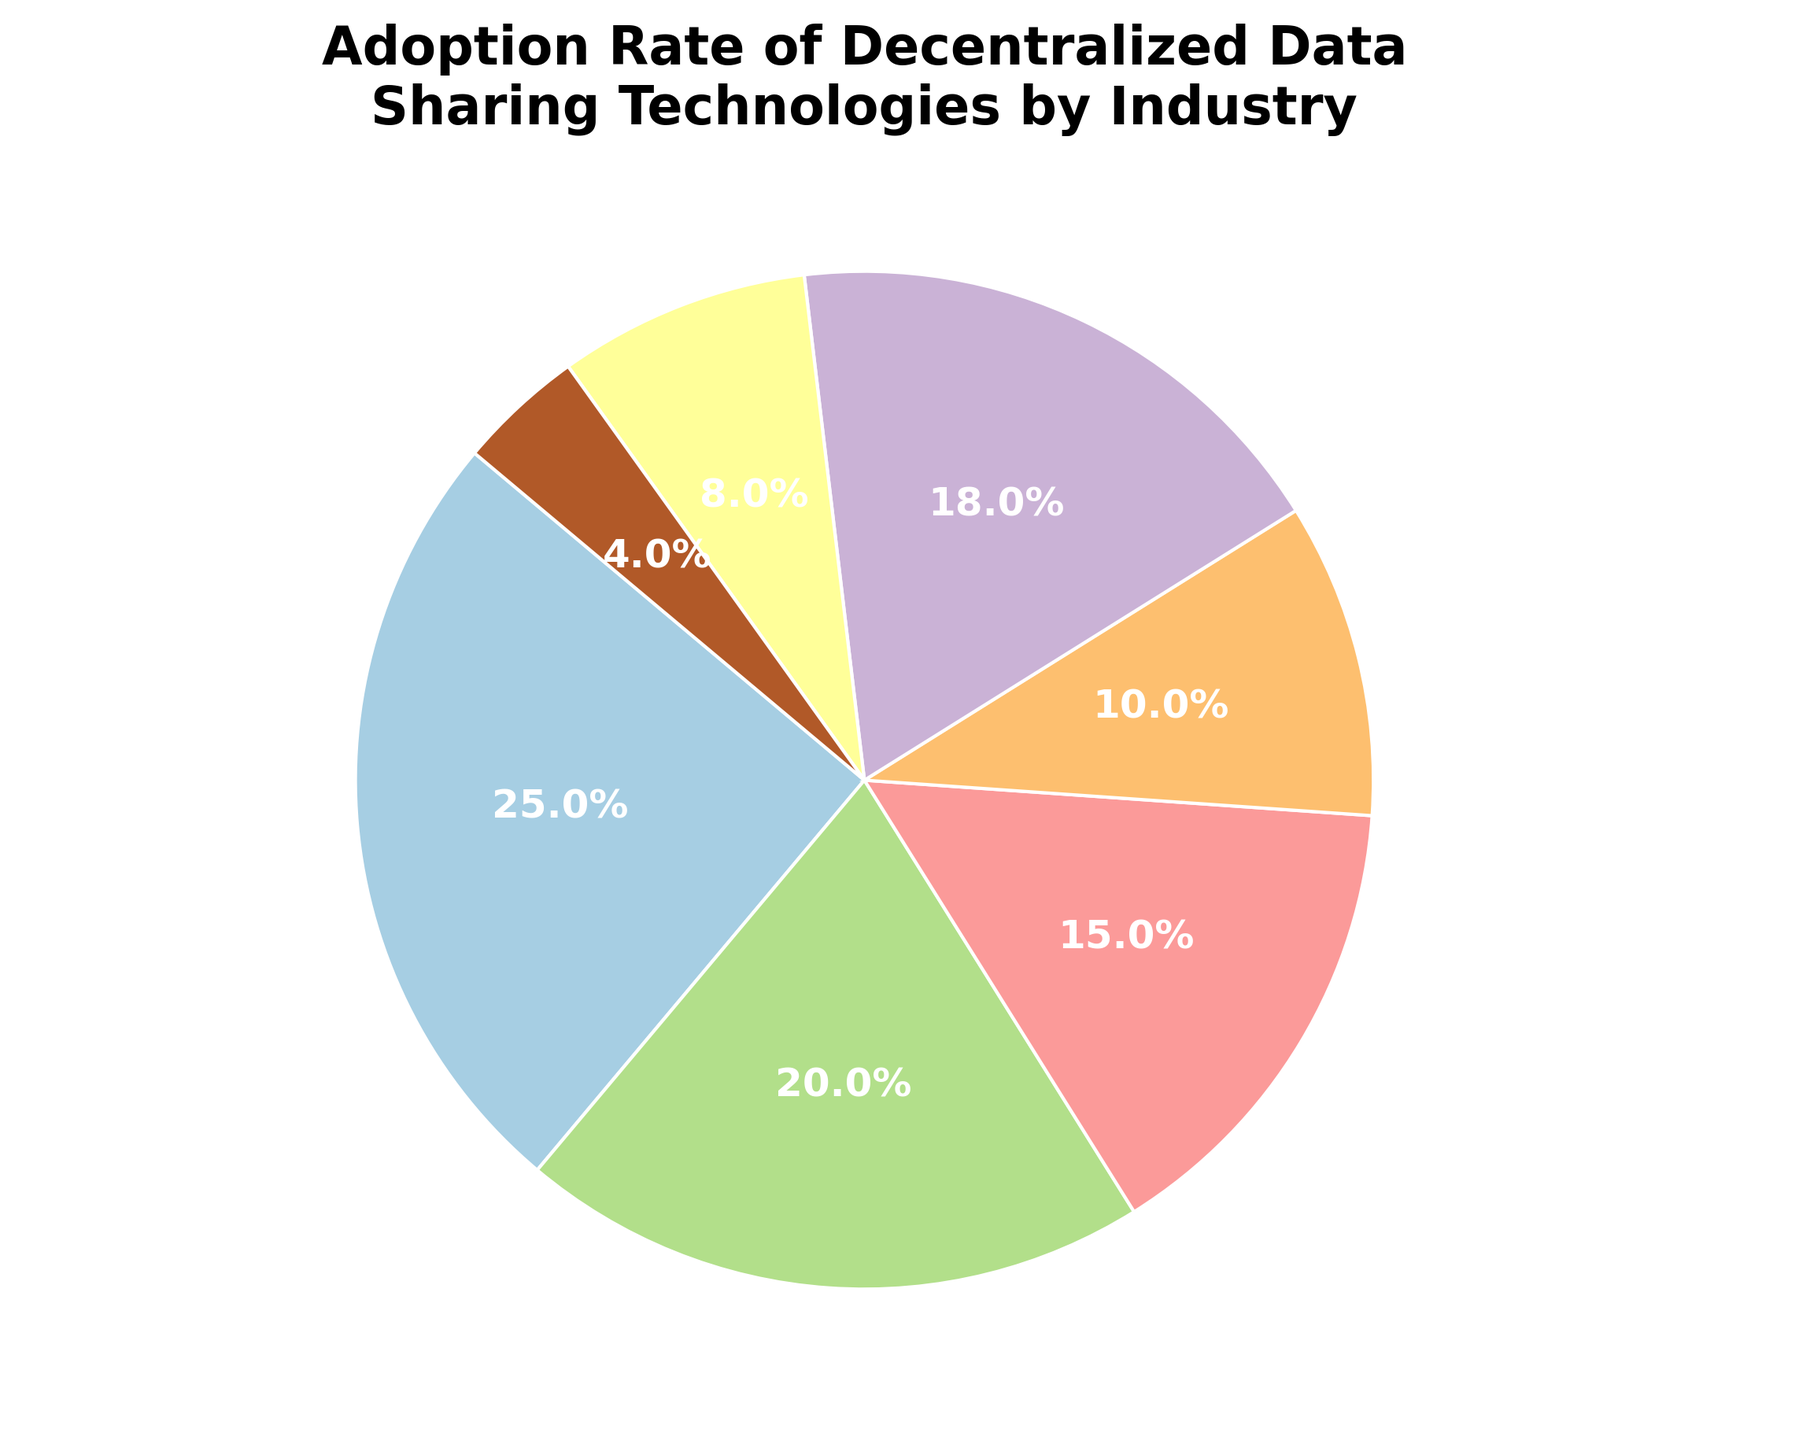What industry has the highest adoption rate of decentralized data sharing technologies? From the pie chart, the slice representing the Healthcare sector is the largest, indicating that it has the highest adoption rate.
Answer: Healthcare Which industry has a lower adoption rate: Finance or Technology? By comparing the sizes of the wedges, it is clear that the Finance sector's wedge is slightly larger than the Technology sector's wedge, meaning Technology has a lower adoption rate.
Answer: Technology What is the combined adoption rate of the Public Sector and Education industries? The Public Sector has an adoption rate of 8% and Education has 4%. Adding these two percentages gives 8% + 4% = 12%.
Answer: 12% Which two industries have the most similar adoption rates, and what are those rates? The Technology industry has an adoption rate of 18% and the Finance industry has an adoption rate of 20%. These rates are the closest among the given data.
Answer: Technology and Finance, 18% and 20% What industry has the smallest adoption rate of decentralized data sharing technologies? From the pie chart, the smallest wedge represents the Education sector.
Answer: Education How does the adoption rate of the Retail industry compare to that of the Manufacturing industry? By looking at the relative sizes of the pie slices, Retail's adoption rate (15%) is larger than Manufacturing's (10%).
Answer: Retail What is the total adoption rate for all industries except Healthcare and Finance? The adoption rates for Retail, Manufacturing, Technology, Public Sector, and Education are 15%, 10%, 18%, 8%, and 4% respectively. Adding these, 15% + 10% + 18% + 8% + 4% = 55%.
Answer: 55% Which two industries together make up more than half of the total adoption rate? The Healthcare industry has an adoption rate of 25% and the Finance industry has 20%. Together, they make up 45%, which is not more than half. Adding Technology (18%) to Healthcare (25%) gives 43%. Adding Healthcare (25%) and Retail (15%) gives 40%. None combine to more than half by simple addition, so no pair exceeds 50%.
Answer: None What is the difference in adoption rate between the sector with the highest adoption and the sector with the lowest adoption? The Healthcare sector has the highest adoption rate at 25%, while Education has the lowest at 4%. The difference is 25% - 4% = 21%.
Answer: 21% Which industries together contribute to exactly one-third of the total adoption rate? One-third of the total adoption rate of 100% is approximately 33.3%. The Technology and Manufacturing industries have rates of 18% and 10% respectively. Adding these to Education gives 18% + 10% + 4% = 32%, which is close but not exact. However, no exact one-third combination exists in the given options.
Answer: None 